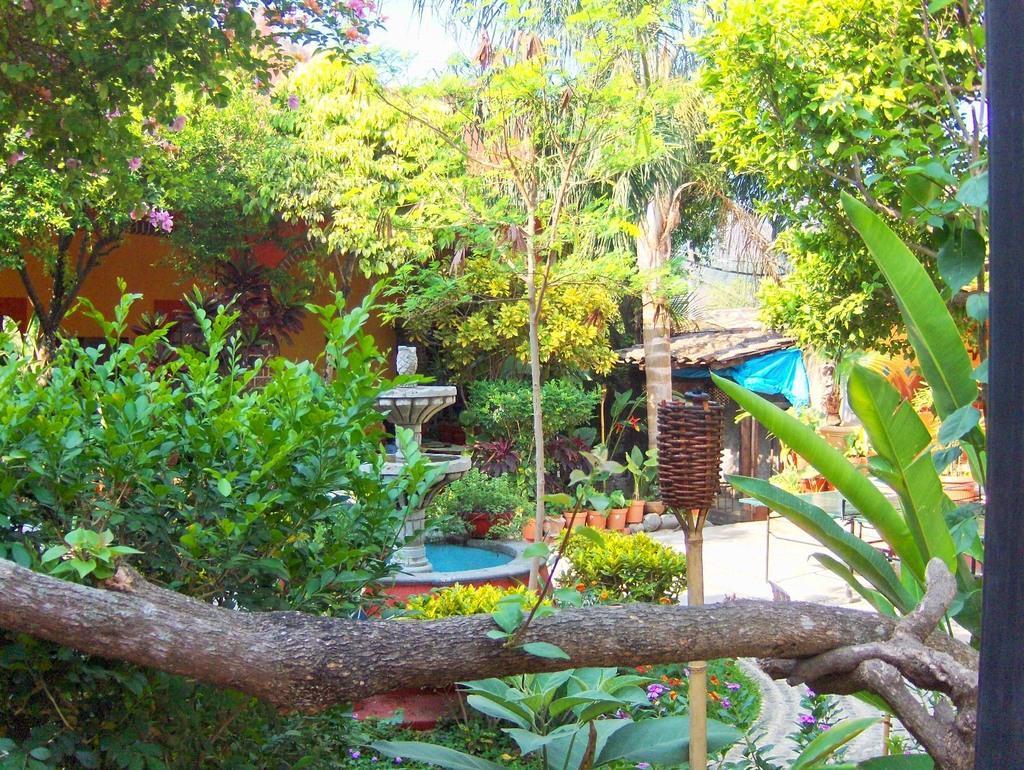Could you give a brief overview of what you see in this image? In this image we can see the trees, plants, flower pots, grass, there is a wooden object, beside we can see an object, behind there is a house, we can see the sky. 